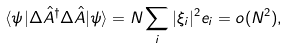<formula> <loc_0><loc_0><loc_500><loc_500>\langle \psi | \Delta \hat { A } ^ { \dagger } \Delta \hat { A } | \psi \rangle = N \sum _ { i } | \xi _ { i } | ^ { 2 } e _ { i } = o ( N ^ { 2 } ) ,</formula> 